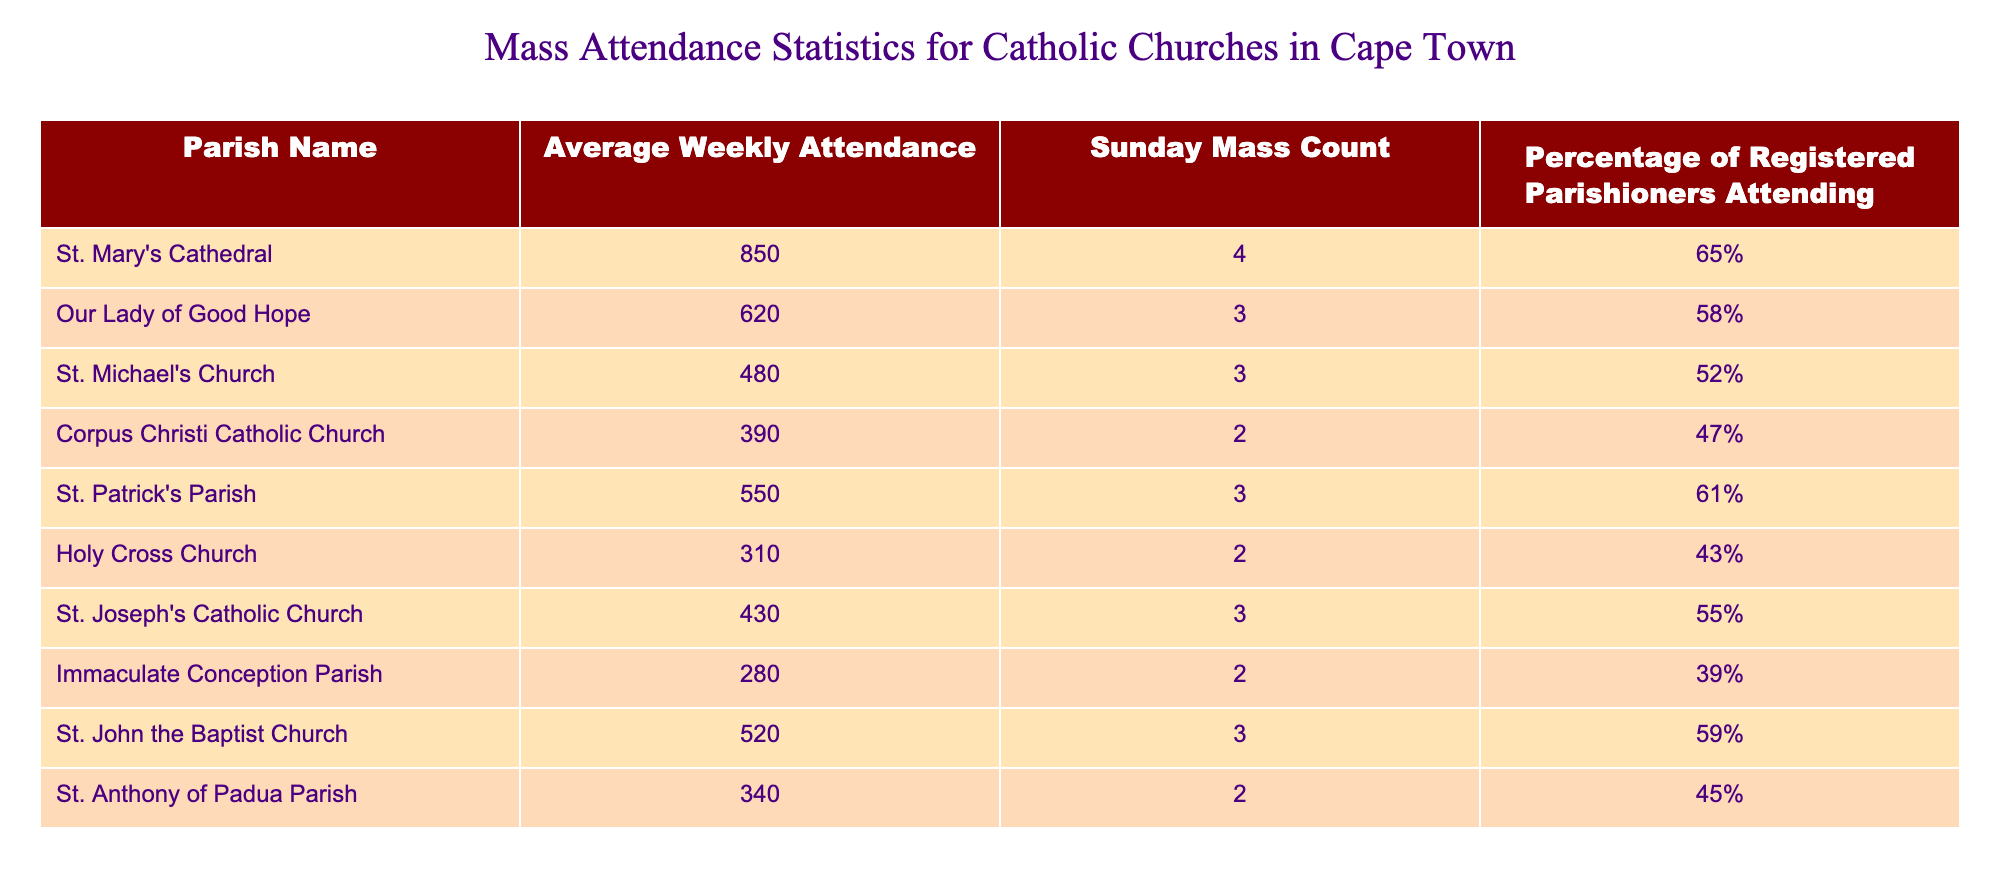What is the average weekly attendance at St. Mary's Cathedral? The table shows that the average weekly attendance at St. Mary's Cathedral is 850. This value is read directly from the "Average Weekly Attendance" column corresponding to that parish.
Answer: 850 How many Sunday Masses are held at Our Lady of Good Hope? According to the table, Our Lady of Good Hope has 3 Sunday Masses. This information is located in the "Sunday Mass Count" column.
Answer: 3 Which parish has the highest percentage of registered parishioners attending? St. Mary's Cathedral has the highest percentage of registered parishioners attending at 65%. This is found by comparing the percentages in the "Percentage of Registered Parishioners Attending" column.
Answer: St. Mary's Cathedral What is the total average weekly attendance of the parishes listed in the table? To find the total average weekly attendance, add the average weekly attendance numbers together: 850 + 620 + 480 + 390 + 550 + 310 + 430 + 280 + 520 + 340 = 4,570.
Answer: 4570 Is the average weekly attendance at St. Patrick's Parish more than 500? The average weekly attendance at St. Patrick's Parish is 550. Since 550 is greater than 500, the statement is true. This is determined by looking up the average attendance in the corresponding row for St. Patrick's Parish.
Answer: Yes Which parish has the lowest average weekly attendance, and what is that attendance? Immaculate Conception Parish has the lowest average weekly attendance at 280. This is identified by scanning through the "Average Weekly Attendance" column and picking out the smallest value.
Answer: Immaculate Conception Parish, 280 What is the difference in average weekly attendance between St. Michael's Church and Holy Cross Church? The average weekly attendance for St. Michael's Church is 480, and for Holy Cross Church, it is 310. The difference is calculated as 480 - 310 = 170.
Answer: 170 Are there more parishes with a weekly attendance above 500 or below 500? There are 4 parishes with attendance above 500 (St. Mary's Cathedral, Our Lady of Good Hope, St. Patrick's Parish, and St. John the Baptist Church) and 6 parishes with attendance below 500 (St. Michael's Church, Corpus Christi Catholic Church, Holy Cross Church, St. Joseph's Catholic Church, Immaculate Conception Parish, and St. Anthony of Padua Parish). Thus, more parishes have attendance below 500.
Answer: Below 500 What is the average percentage of registered parishioners attending across all parishes? To find this average percentage, first add the percentages together: 65 + 58 + 52 + 47 + 61 + 43 + 55 + 39 + 59 + 45 =  465. There are 10 parishes, so average = 465 / 10 = 46.5%.
Answer: 46.5% 